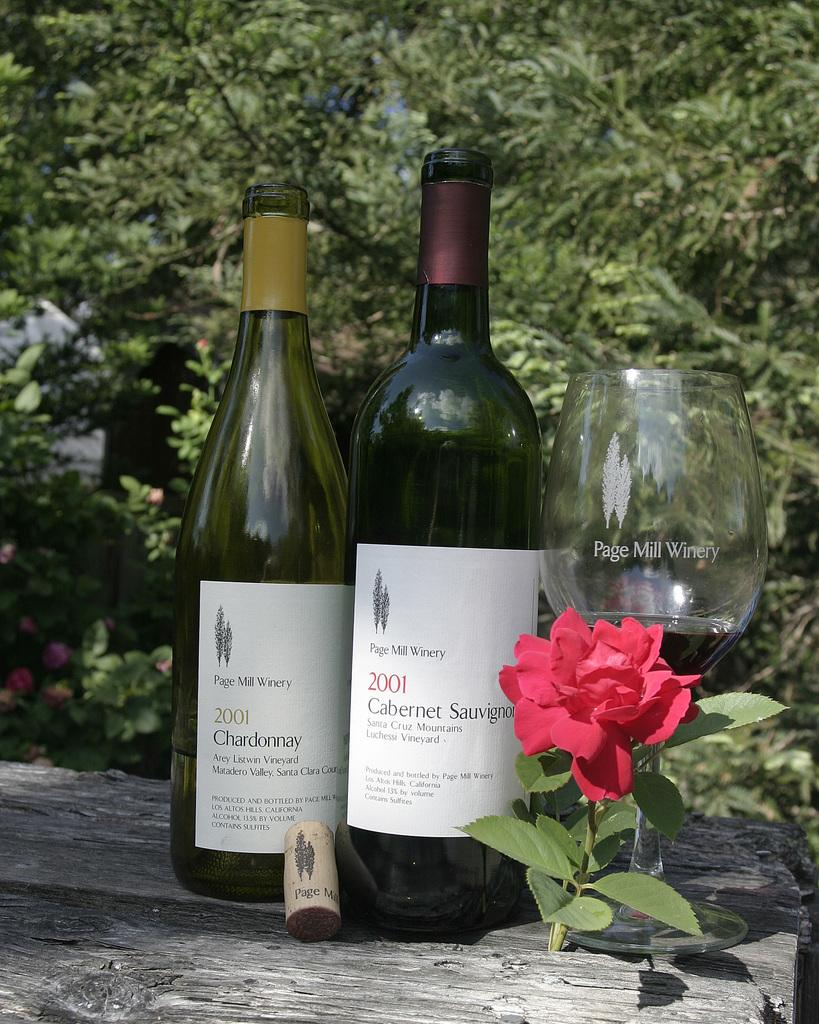<image>
Offer a succinct explanation of the picture presented. Page Mill Winery made these great wines in 2001. 